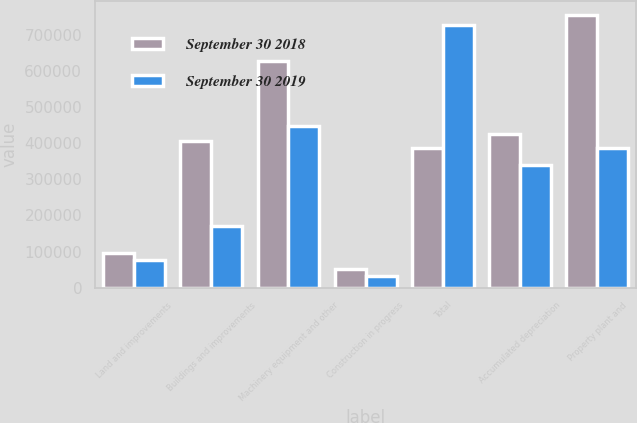Convert chart. <chart><loc_0><loc_0><loc_500><loc_500><stacked_bar_chart><ecel><fcel>Land and improvements<fcel>Buildings and improvements<fcel>Machinery equipment and other<fcel>Construction in progress<fcel>Total<fcel>Accumulated depreciation<fcel>Property plant and<nl><fcel>September 30 2018<fcel>95536<fcel>407461<fcel>628096<fcel>52241<fcel>388333<fcel>426577<fcel>756757<nl><fcel>September 30 2019<fcel>77455<fcel>171269<fcel>448014<fcel>31237<fcel>727975<fcel>339642<fcel>388333<nl></chart> 